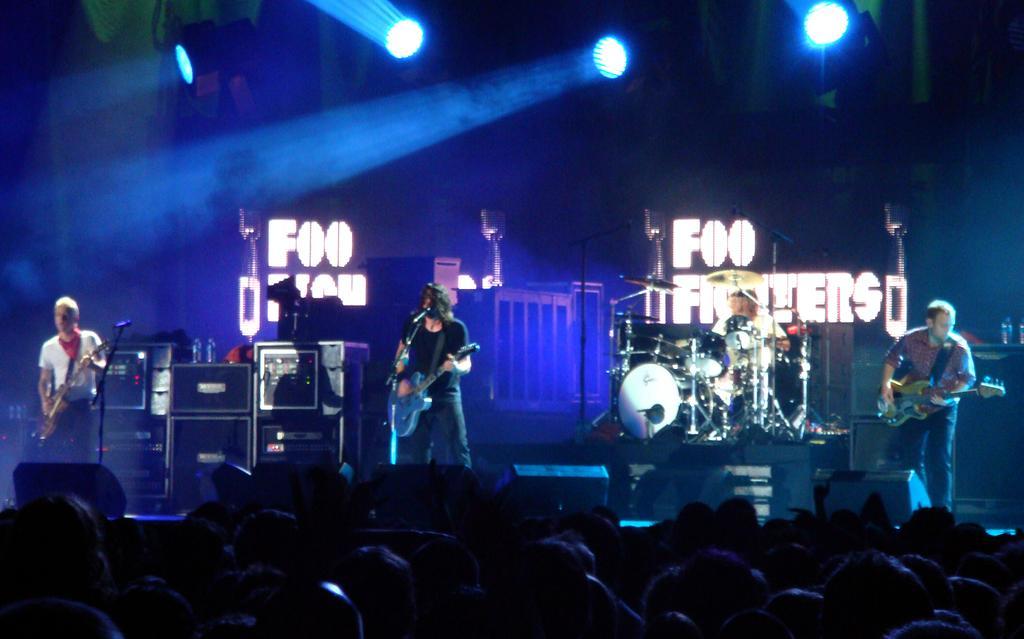How would you summarize this image in a sentence or two? Here we can see a band of 4 performing on stage, three of them are playing a guitar with microphone in front of them and the person in the middle is playing drums and there are colorful lights present and in front of them we can see a set of audience present and there are other musical instruments on the stage 